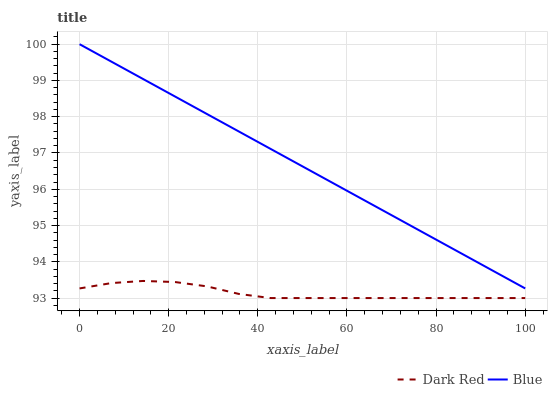Does Dark Red have the minimum area under the curve?
Answer yes or no. Yes. Does Blue have the maximum area under the curve?
Answer yes or no. Yes. Does Dark Red have the maximum area under the curve?
Answer yes or no. No. Is Blue the smoothest?
Answer yes or no. Yes. Is Dark Red the roughest?
Answer yes or no. Yes. Is Dark Red the smoothest?
Answer yes or no. No. Does Dark Red have the lowest value?
Answer yes or no. Yes. Does Blue have the highest value?
Answer yes or no. Yes. Does Dark Red have the highest value?
Answer yes or no. No. Is Dark Red less than Blue?
Answer yes or no. Yes. Is Blue greater than Dark Red?
Answer yes or no. Yes. Does Dark Red intersect Blue?
Answer yes or no. No. 